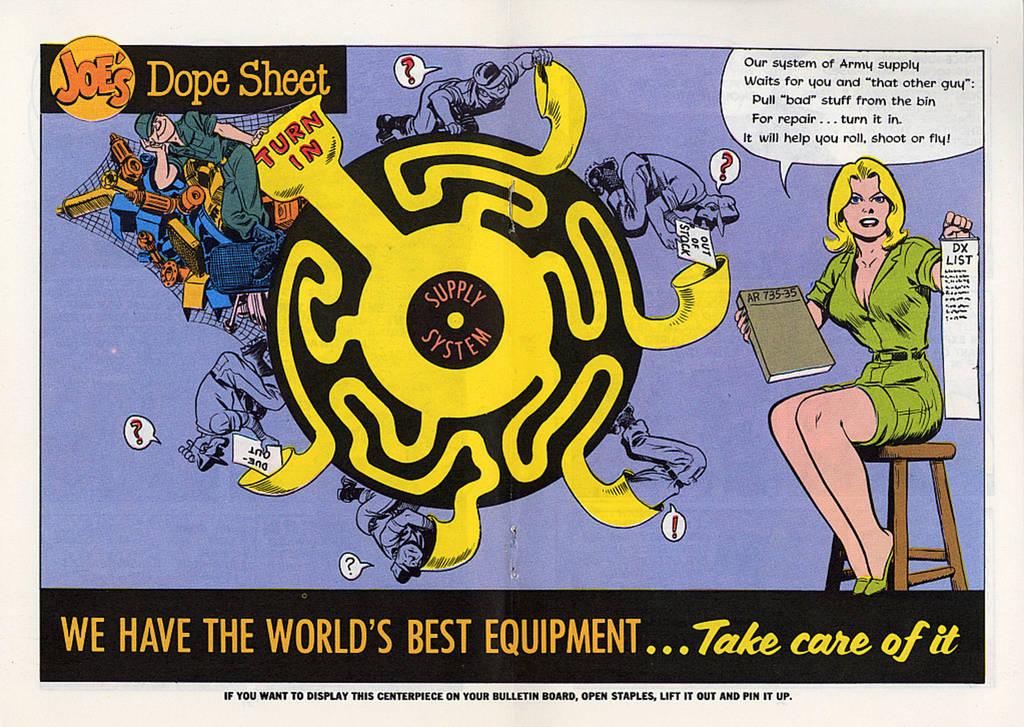Who has the world's best equipment?
Make the answer very short. Joe's. Is joe's dope sheet a comic?
Make the answer very short. Yes. 